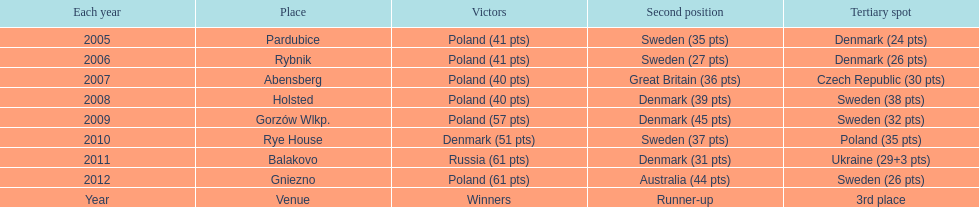After their first place win in 2009, how did poland place the next year at the speedway junior world championship? 3rd place. 